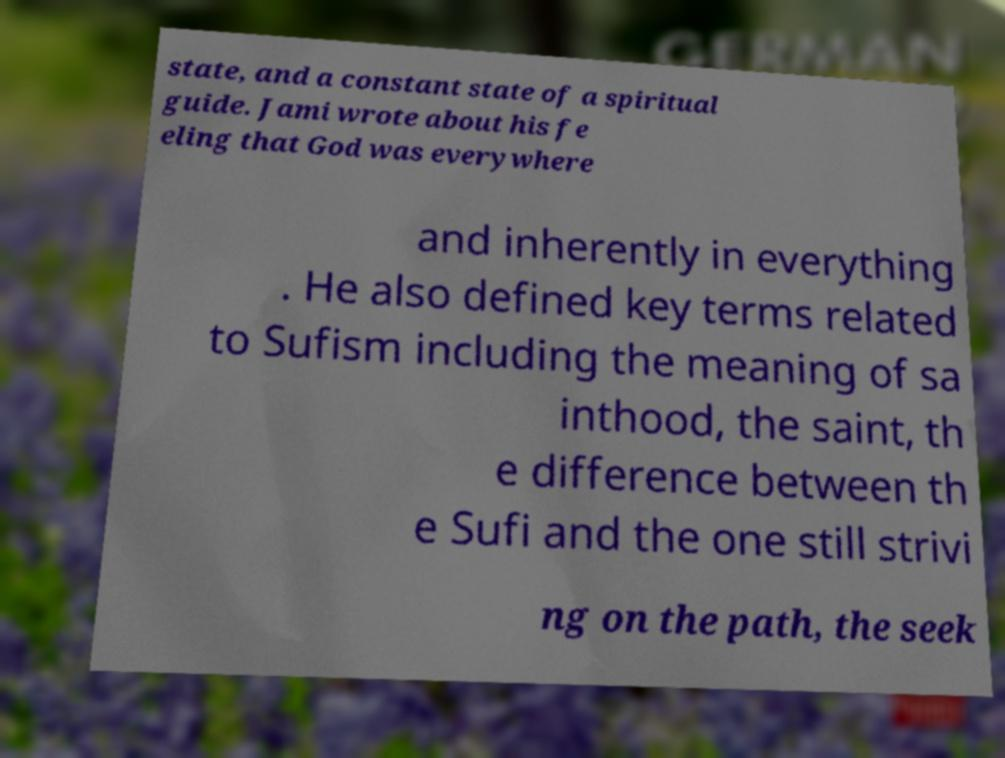Could you assist in decoding the text presented in this image and type it out clearly? state, and a constant state of a spiritual guide. Jami wrote about his fe eling that God was everywhere and inherently in everything . He also defined key terms related to Sufism including the meaning of sa inthood, the saint, th e difference between th e Sufi and the one still strivi ng on the path, the seek 